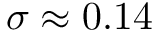<formula> <loc_0><loc_0><loc_500><loc_500>\sigma \approx 0 . 1 4</formula> 